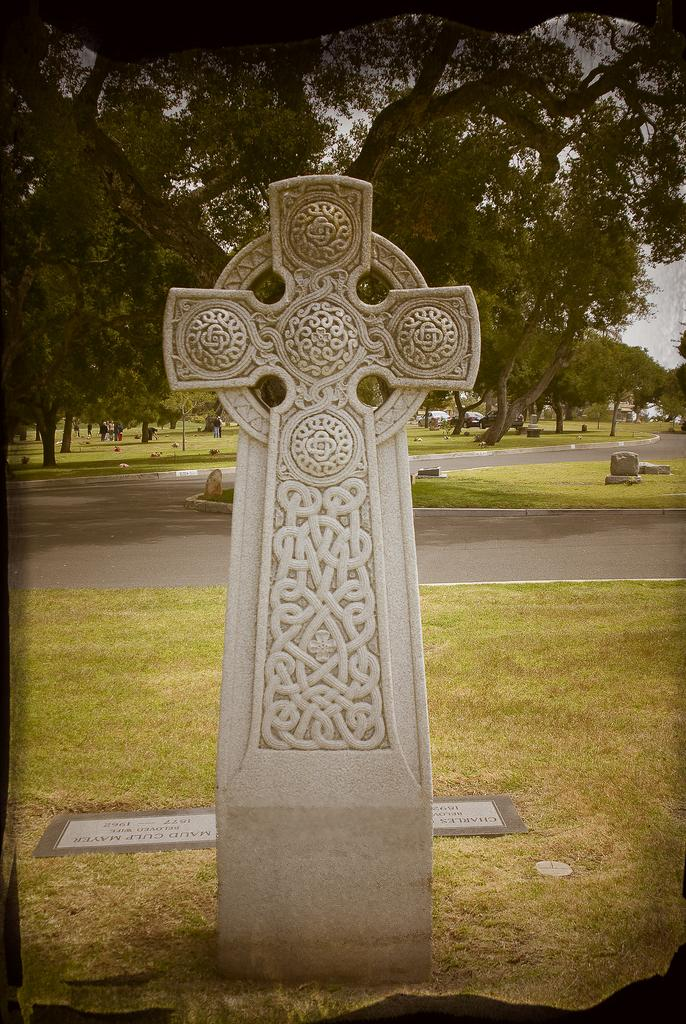What is the main subject in the front of the image? There is a memorial stone in the front of the image. What can be seen in the background of the image? There is a board, grass, a road, stones, trees, and the sky visible in the background of the image. How many different elements can be seen in the background of the image? There are six different elements visible in the background of the image: a board, grass, a road, stones, trees, and the sky. What type of rings can be seen on the plate in the image? There is no plate or rings present in the image. How many cherries are on the tree in the image? There is no tree or cherries present in the image. 